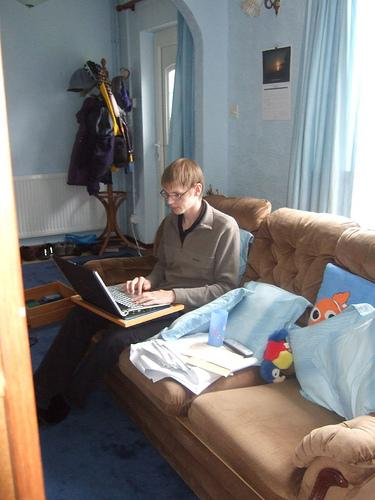The fish on the pillow goes by what name? nemo 